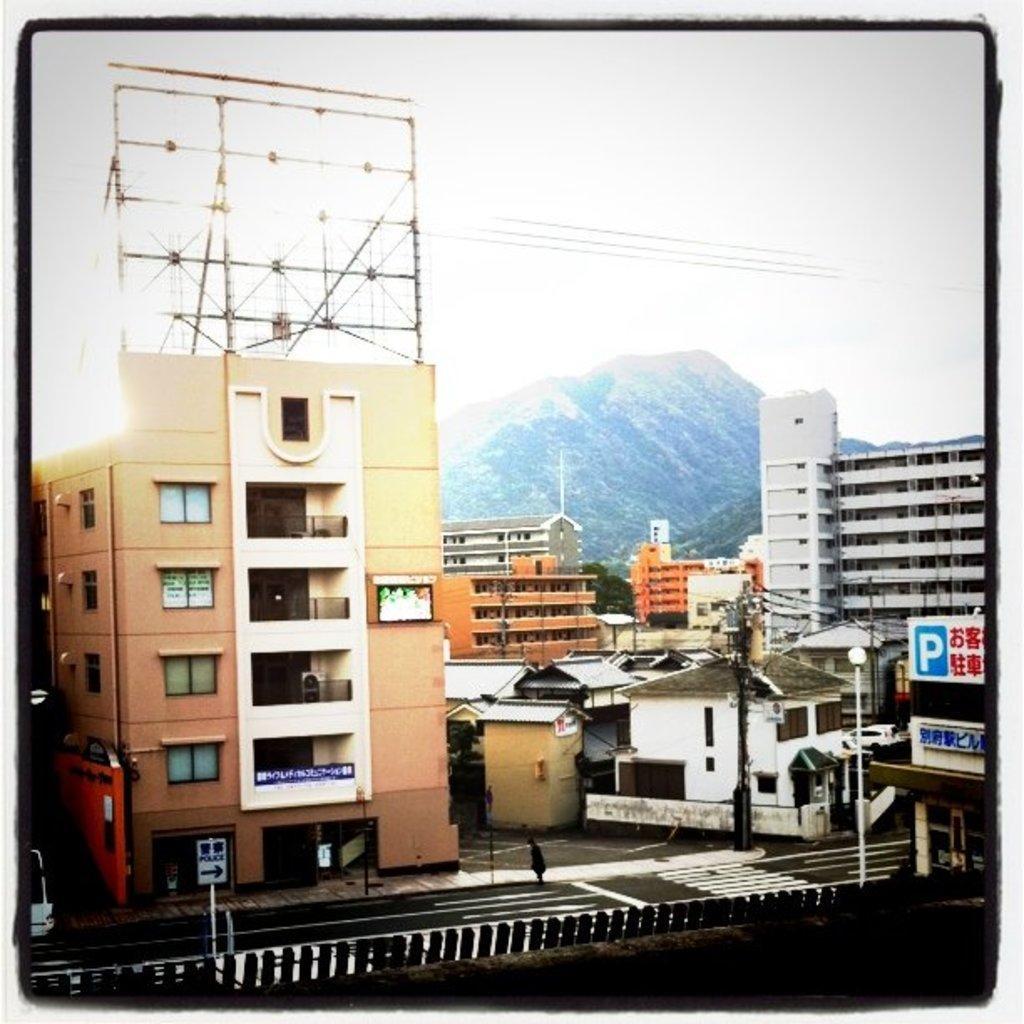Can you describe this image briefly? In the background we can see the sky, hills and the thicket. We can see the buildings, transmission wires. In this picture we can see the rooftops, poles, light pole,hoardings, sign board. We can see the hoarding stand at the top of a building. A person is visible on the road. We can see the railing. 